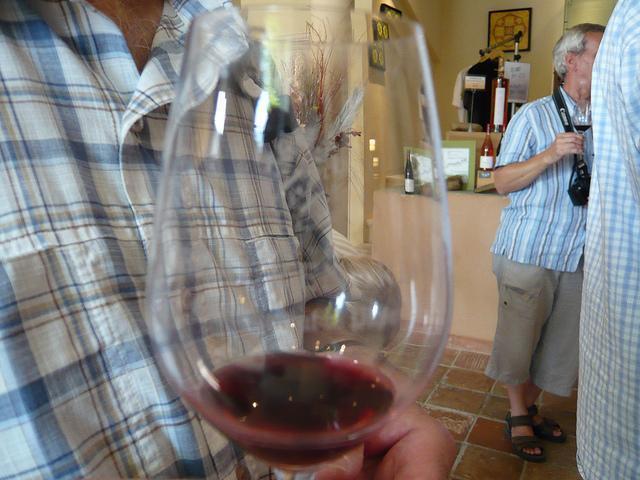How many people are visible?
Give a very brief answer. 3. How many birds are pictured?
Give a very brief answer. 0. 